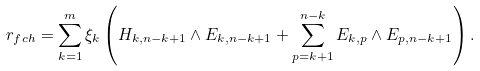<formula> <loc_0><loc_0><loc_500><loc_500>r _ { f c h } = \sum _ { k = 1 } ^ { m } \xi _ { k } \left ( H _ { k , n - k + 1 } \wedge E _ { k , n - k + 1 } + \sum _ { p = k + 1 } ^ { n - k } E _ { k , p } \wedge E _ { p , n - k + 1 } \right ) .</formula> 